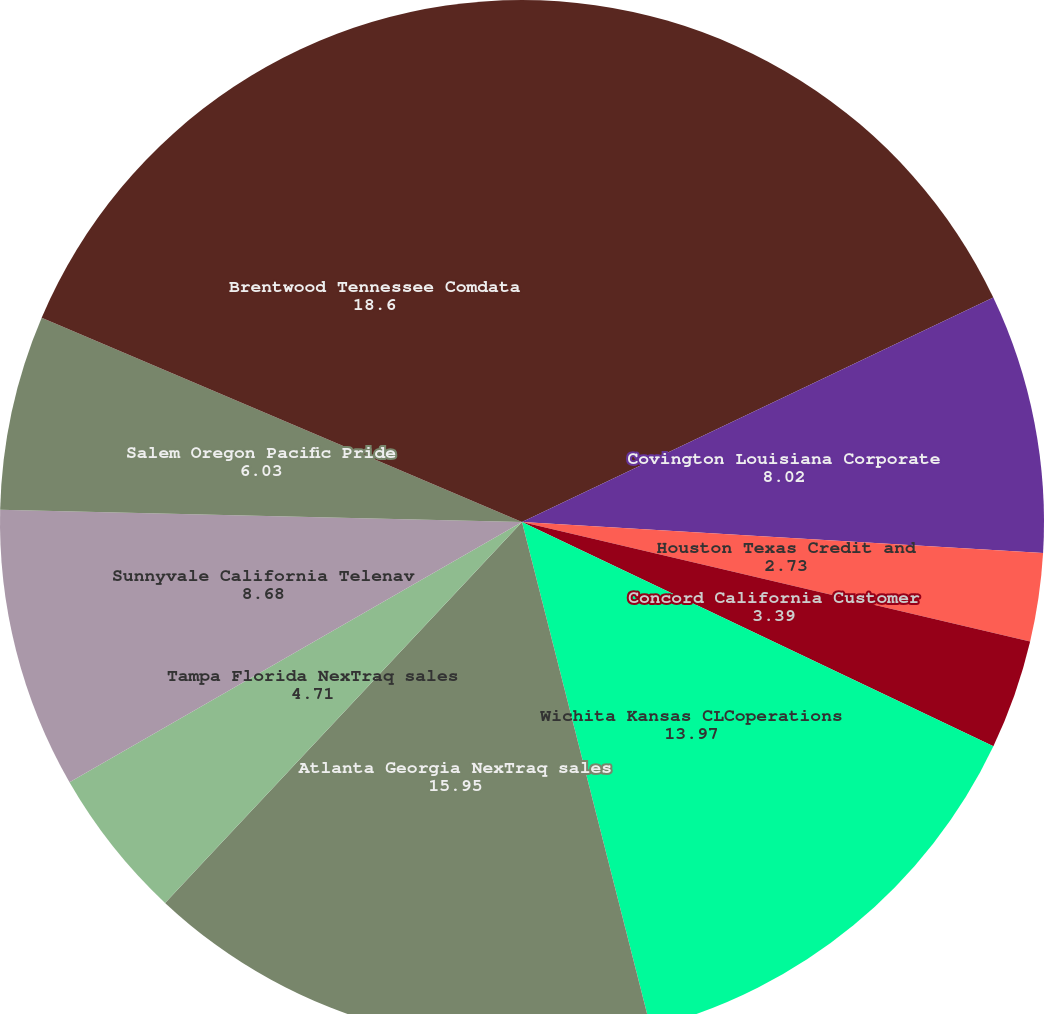Convert chart. <chart><loc_0><loc_0><loc_500><loc_500><pie_chart><fcel>Norcross Georgia Corporate<fcel>Covington Louisiana Corporate<fcel>Houston Texas Credit and<fcel>Concord California Customer<fcel>Wichita Kansas CLCoperations<fcel>Atlanta Georgia NexTraq sales<fcel>Tampa Florida NexTraq sales<fcel>Sunnyvale California Telenav<fcel>Salem Oregon Pacific Pride<fcel>Brentwood Tennessee Comdata<nl><fcel>17.93%<fcel>8.02%<fcel>2.73%<fcel>3.39%<fcel>13.97%<fcel>15.95%<fcel>4.71%<fcel>8.68%<fcel>6.03%<fcel>18.6%<nl></chart> 